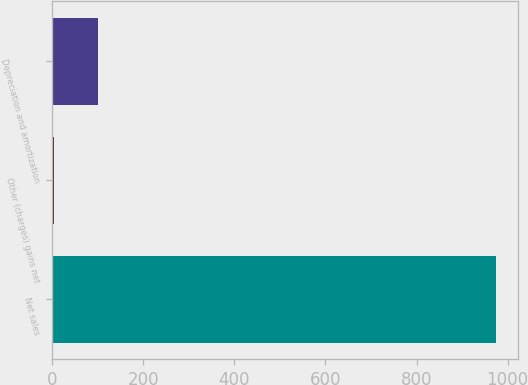<chart> <loc_0><loc_0><loc_500><loc_500><bar_chart><fcel>Net sales<fcel>Other (charges) gains net<fcel>Depreciation and amortization<nl><fcel>974<fcel>4<fcel>101<nl></chart> 